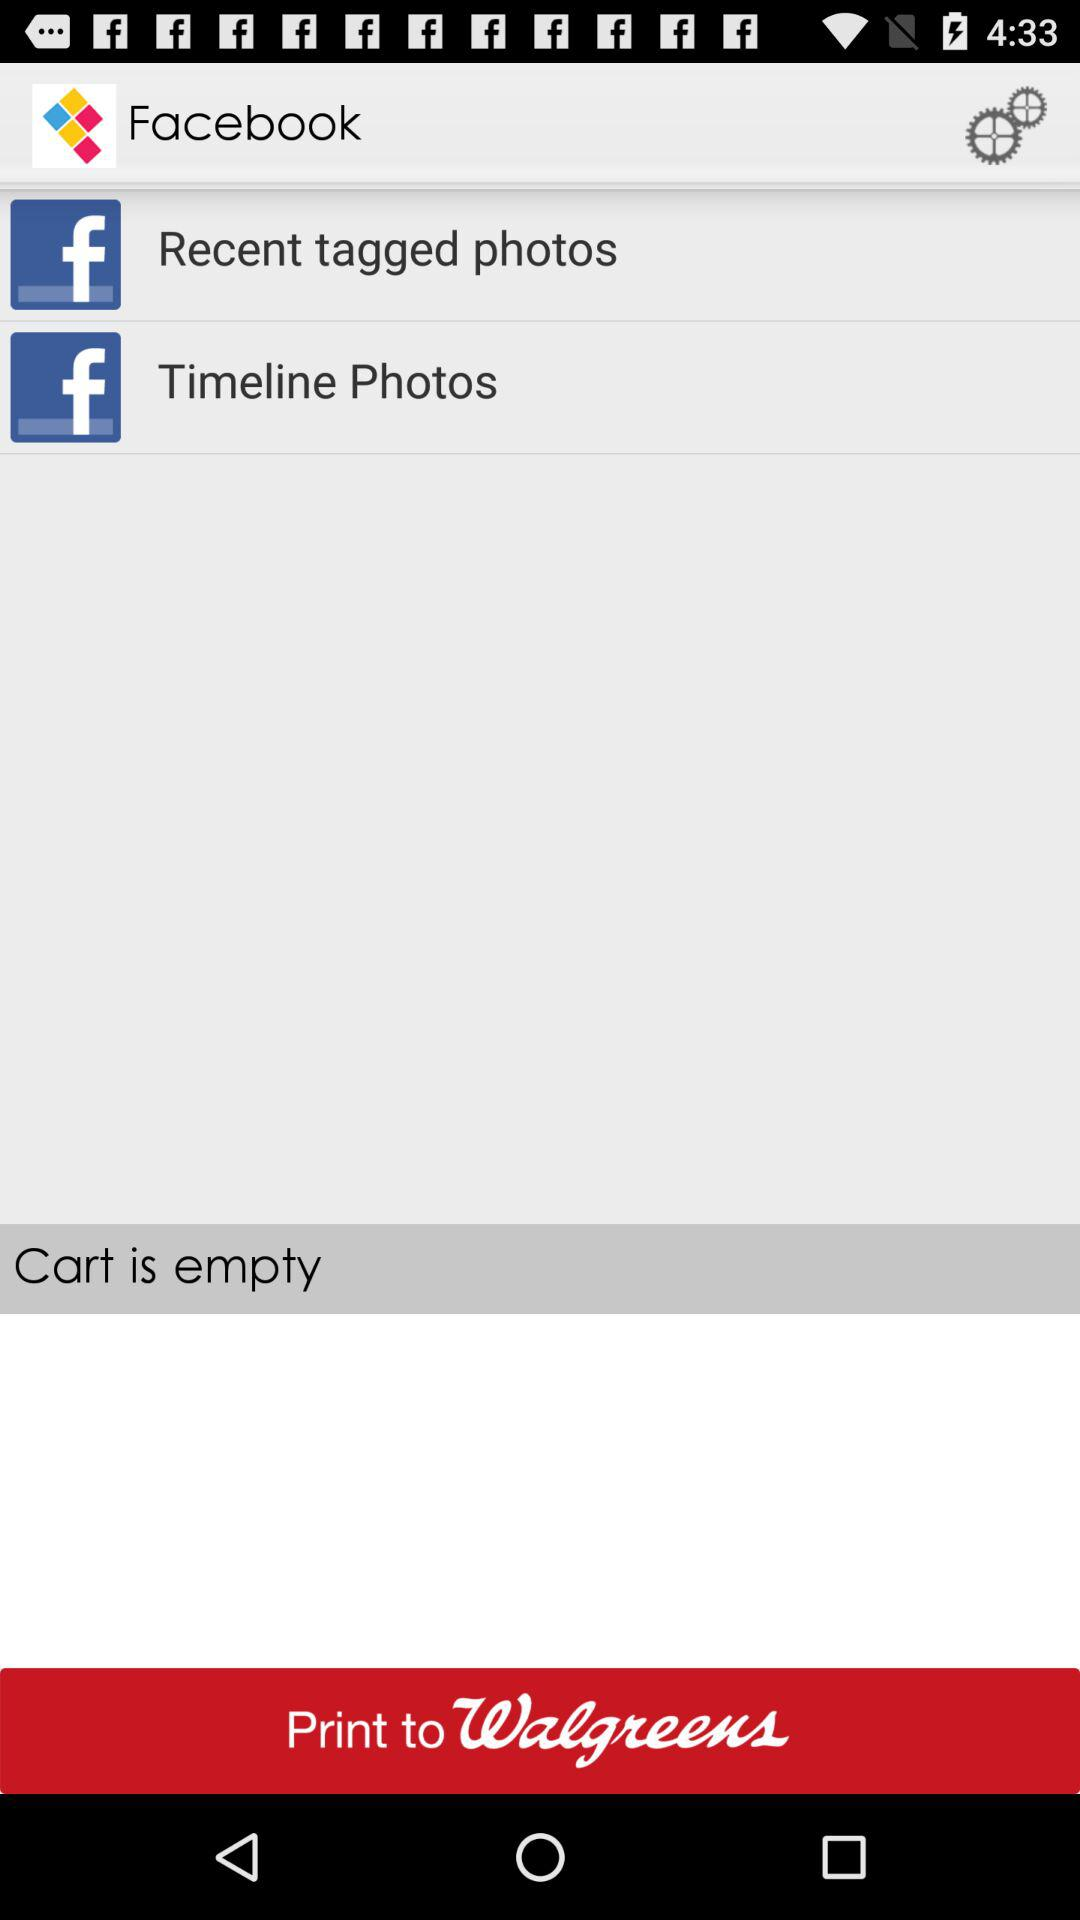What is the application name? The application name is Facebook. 